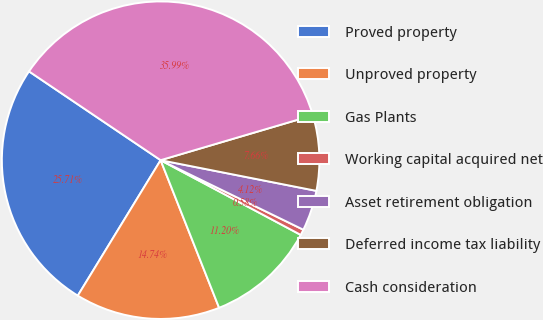<chart> <loc_0><loc_0><loc_500><loc_500><pie_chart><fcel>Proved property<fcel>Unproved property<fcel>Gas Plants<fcel>Working capital acquired net<fcel>Asset retirement obligation<fcel>Deferred income tax liability<fcel>Cash consideration<nl><fcel>25.71%<fcel>14.74%<fcel>11.2%<fcel>0.58%<fcel>4.12%<fcel>7.66%<fcel>35.99%<nl></chart> 